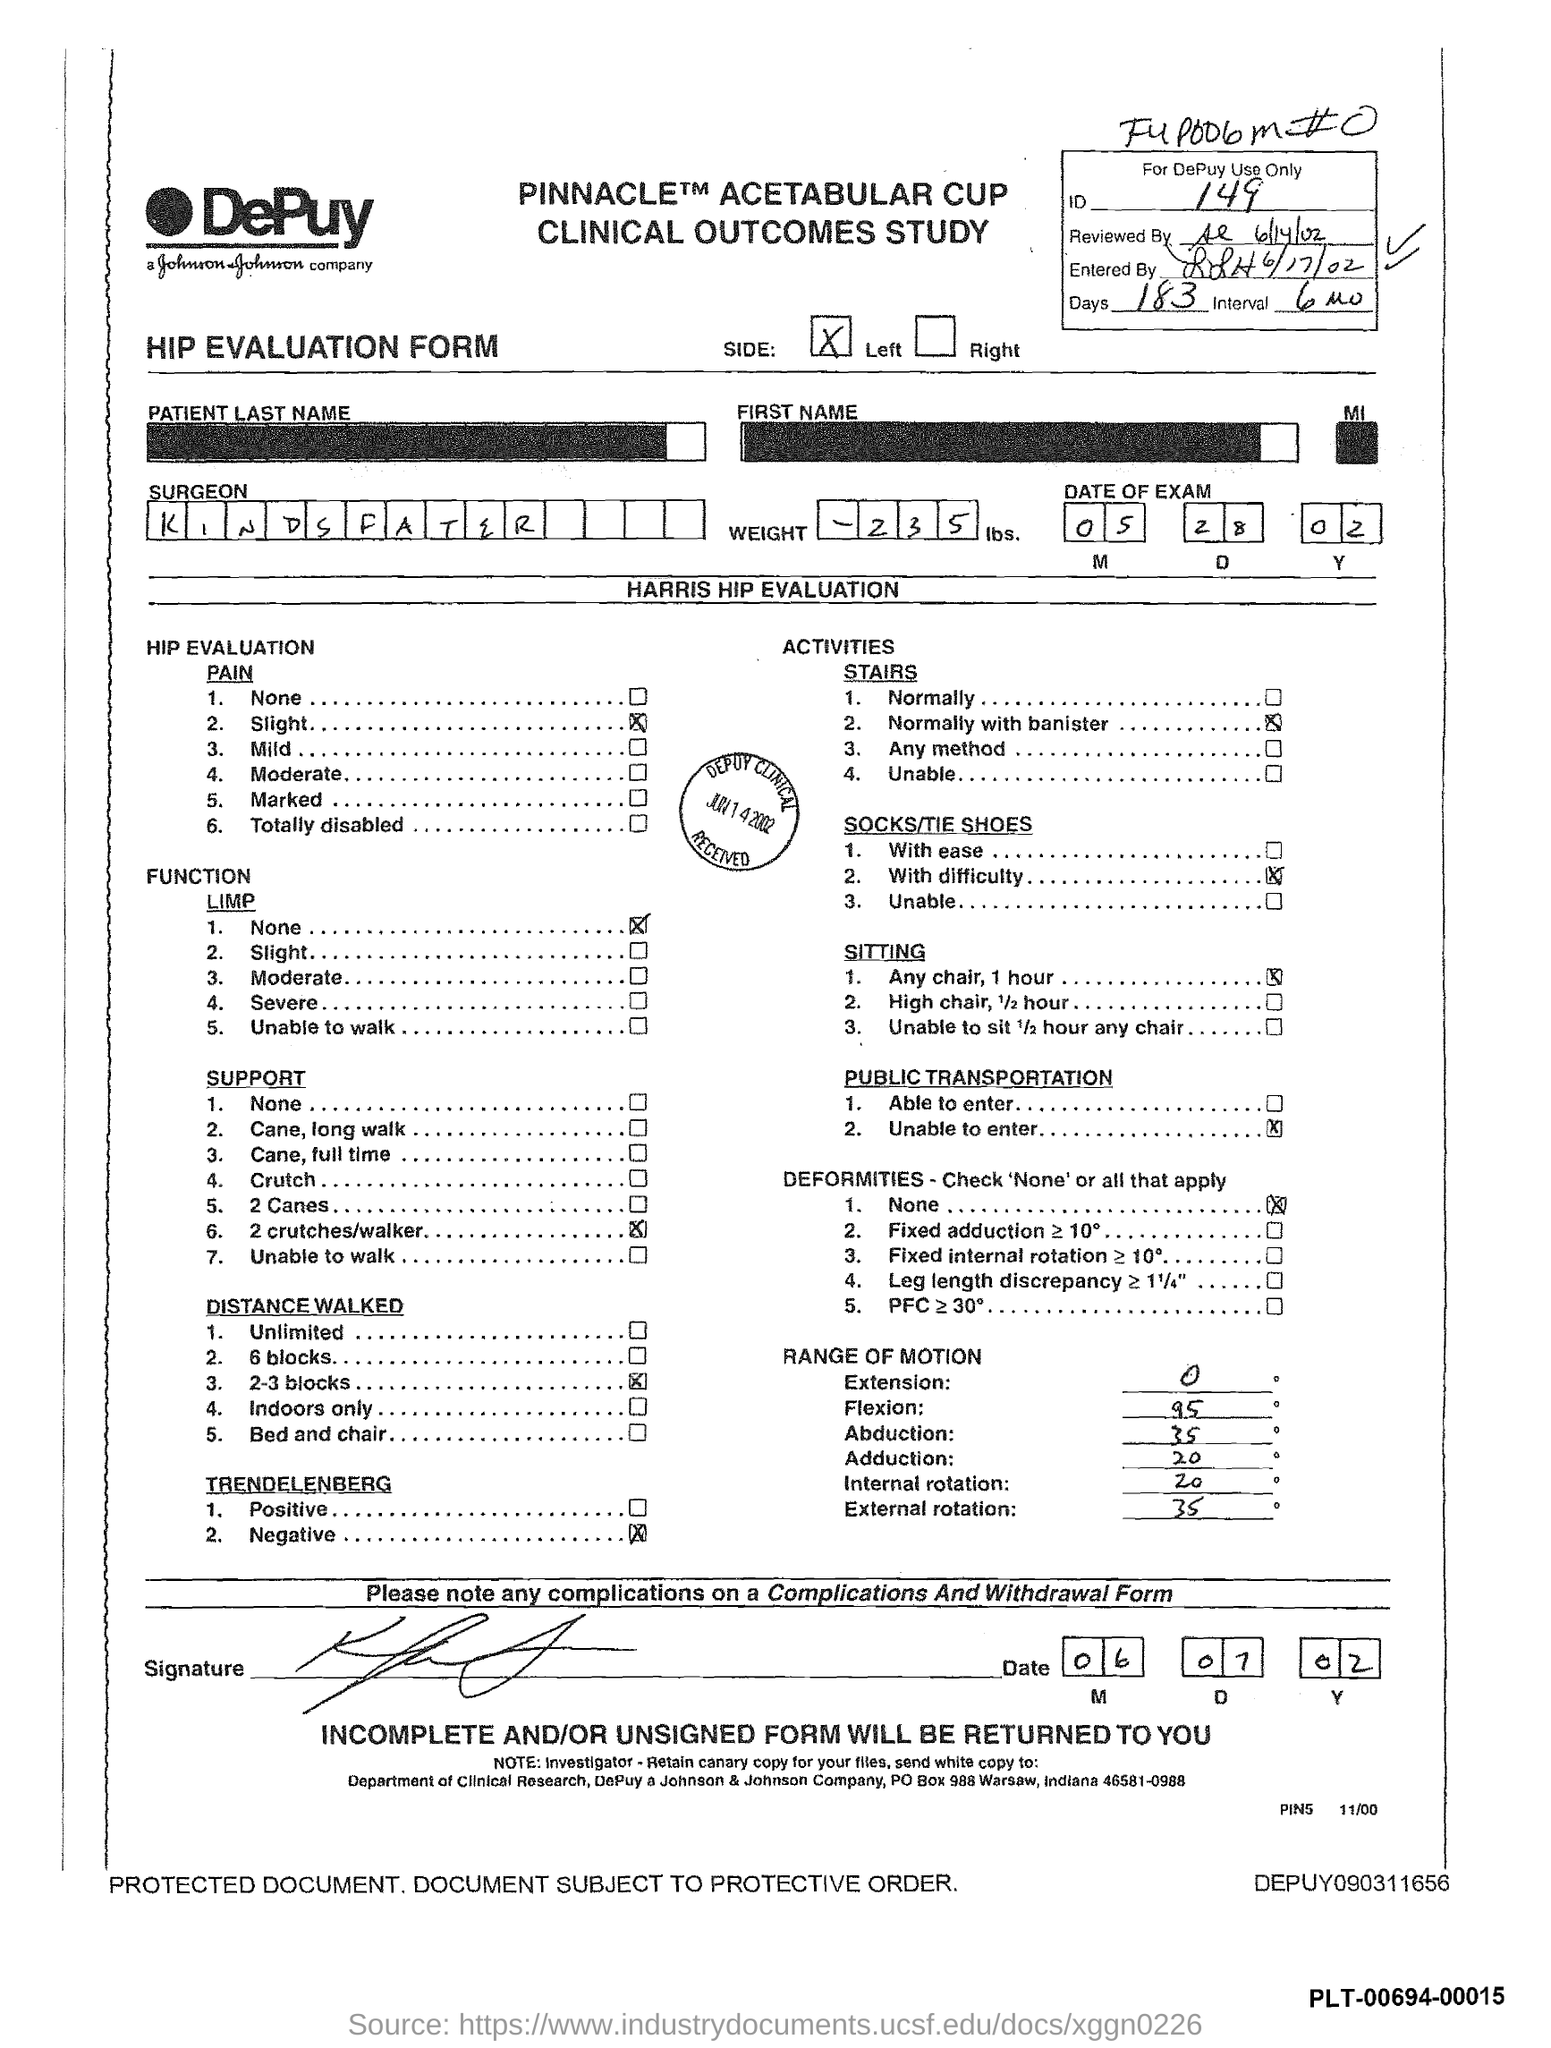Point out several critical features in this image. The range of motion for external rotation is 35 degrees. There are 183 days mentioned in the form. The name of the company is DePuy Johnson & Johnson Company. The range of motion for adduction is from 20 to 135 degrees. The weight mentioned is 235... 